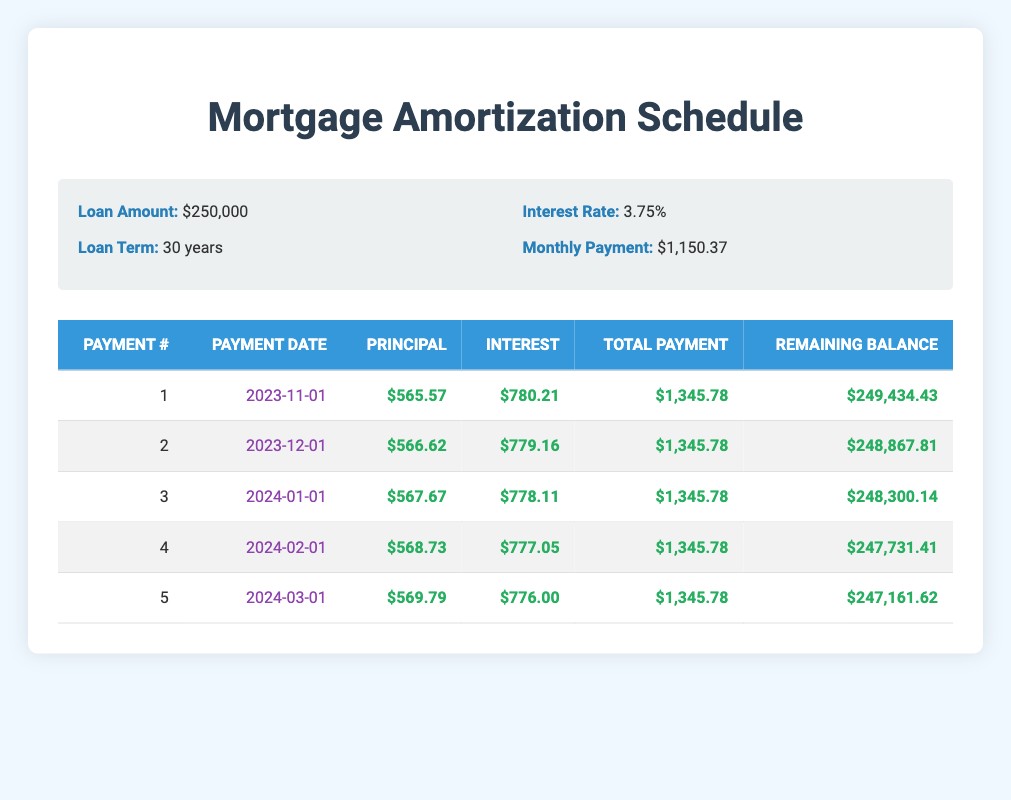What is the total monthly payment for the mortgage? The total monthly payment is listed in the loan details section of the table. It states that the monthly payment is $1,150.37.
Answer: $1,150.37 What is the principal payment for the first month? The principal payment for the first month is directly taken from the first row of the amortization schedule, which indicates it is $565.57.
Answer: $565.57 Is the interest payment on the first month higher than the principal payment? The first month's interest payment is $780.21, which is higher than the principal payment of $565.57 as shown in the first row of the table.
Answer: Yes What is the remaining balance after the second payment? The remaining balance after the second payment can be found in the second row of the table, which states it is $248,867.81.
Answer: $248,867.81 What is the total principal paid after the first five payments? To find the total principal paid after the first five payments, add up all principal payments: $565.57 + $566.62 + $567.67 + $568.73 + $569.79 = $2,838.38.
Answer: $2,838.38 What is the average interest payment over the first five months? The interest payments for the first five months are $780.21, $779.16, $778.11, $777.05, and $776.00. To find the average, we sum these amounts: $780.21 + $779.16 + $778.11 + $777.05 + $776.00 = $3,890.53, and then divide by 5. The average interest payment is $3,890.53 / 5 = $778.11.
Answer: $778.11 What is the difference between the total payment and the principal payment for the first month? The total payment for the first month is $1,345.78 and the principal payment is $565.57. The difference is $1,345.78 - $565.57 = $780.21, which is the interest portion for that month.
Answer: $780.21 After the third payment, what is the remaining balance? Referring to the amortization schedule, the remaining balance after the third payment is $248,300.14, as indicated in the third row of the table.
Answer: $248,300.14 Is the monthly payment the same for the first five months? The total payment for the first five months has remained constant at $1,345.78 for each month as indicated in the table.
Answer: Yes 